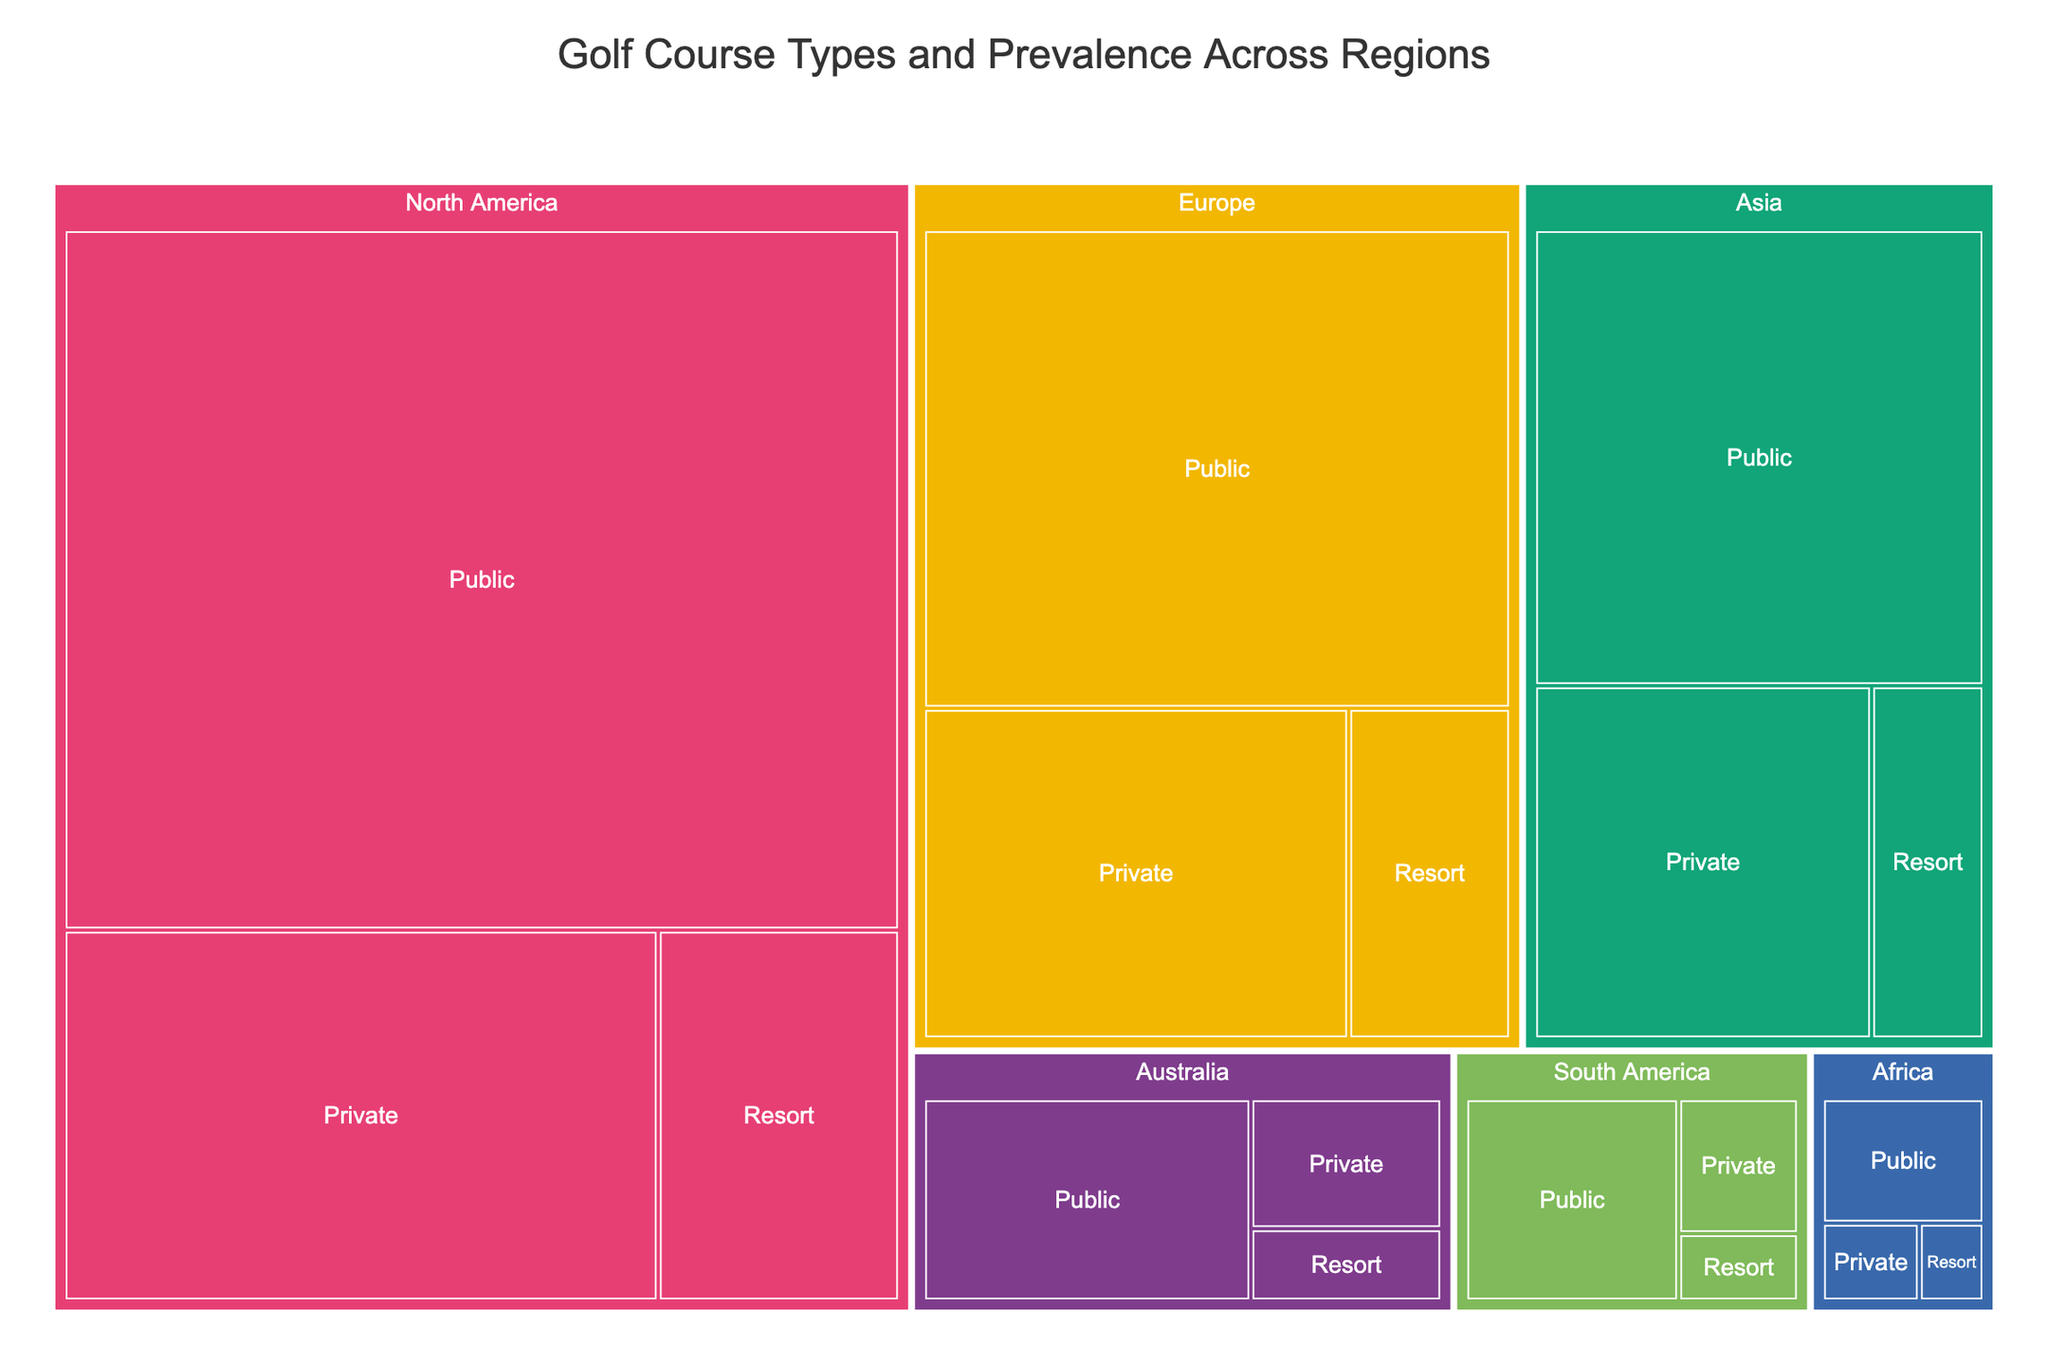What region has the highest number of public courses? The treemap shows the number of public courses by region. North America has the largest size for public courses.
Answer: North America How many private courses are there in Asia? The treemap displays 1,800 private courses for Asia.
Answer: 1,800 Which region has the smallest number of courses overall? Compare the sizes of the regions for each course type. Africa has the smallest sections in all categories.
Answer: Africa What's the total number of resort courses in North America and Europe combined? Add the number of resort courses in North America (1,300) and Europe (800).
Answer: 2,100 Which region has more private courses, Europe or Australia? Look at the private courses sections for Europe and Australia on the treemap. Europe has a larger section for private courses.
Answer: Europe What type of course is most prevalent in Europe? The largest section in the Europe region is for public courses.
Answer: Public How many more public courses are there in North America compared to Asia? Subtract the number of public courses in Asia (3,100) from North America (8,500).
Answer: 5,400 Which course type is least common in South America? The smallest section for South America in the treemap is resort courses.
Answer: Resort What's the total number of golf courses in Australia? Add the number of public (1,200), private (450), and resort (250) courses in Australia.
Answer: 1,900 Which region has the second highest number of resort courses? Resort course sections are compared across regions; Europe has the second largest after North America.
Answer: Europe 